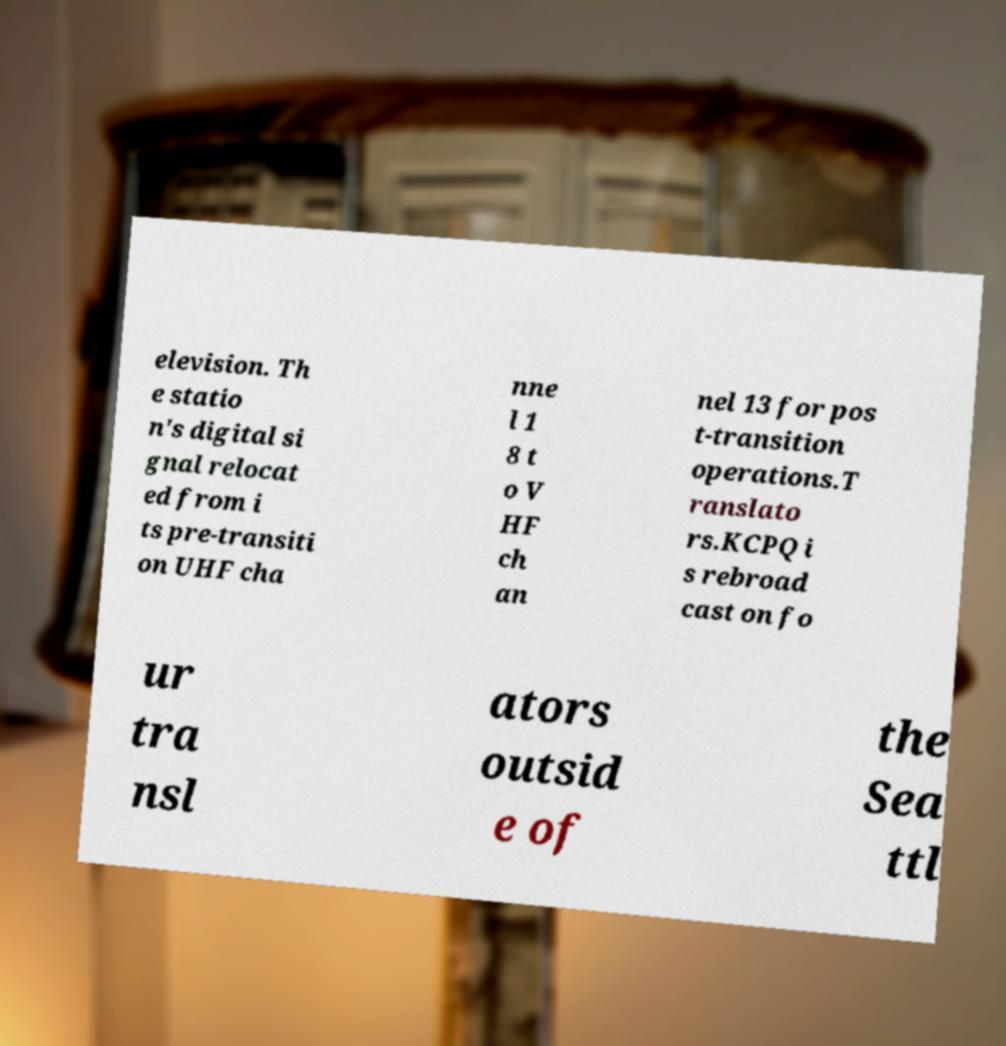For documentation purposes, I need the text within this image transcribed. Could you provide that? elevision. Th e statio n's digital si gnal relocat ed from i ts pre-transiti on UHF cha nne l 1 8 t o V HF ch an nel 13 for pos t-transition operations.T ranslato rs.KCPQ i s rebroad cast on fo ur tra nsl ators outsid e of the Sea ttl 